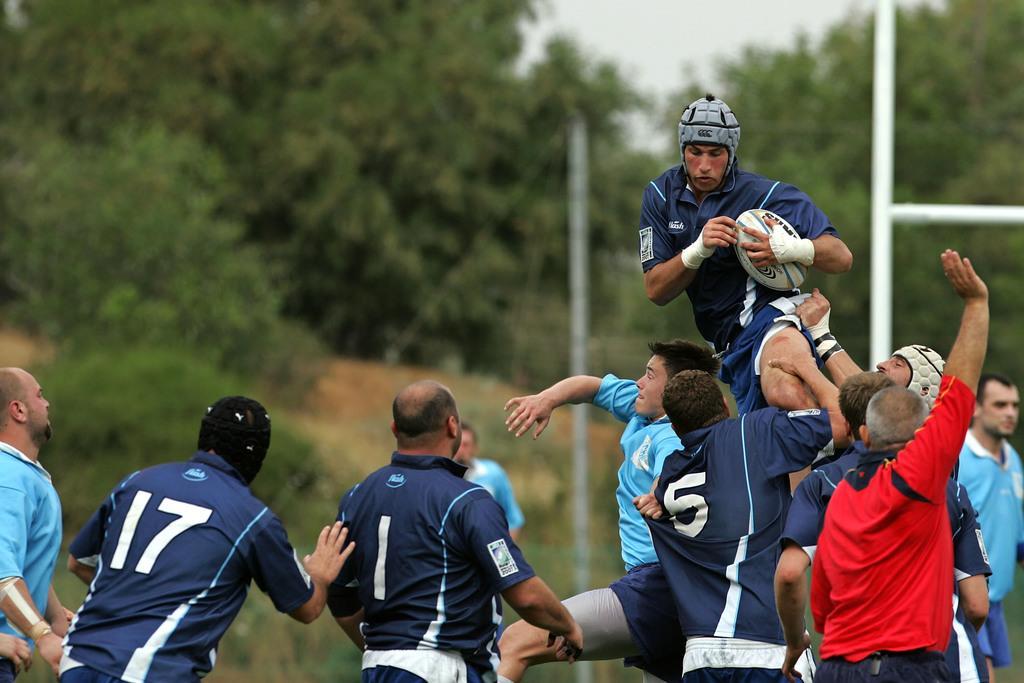Could you give a brief overview of what you see in this image? In this image I can see group of people are playing with the ball. The ball is in white color. These people are wearing the jersey. Among them one person is wearing the red color t-shirt. In the back there are trees , the white pole and the sky. 